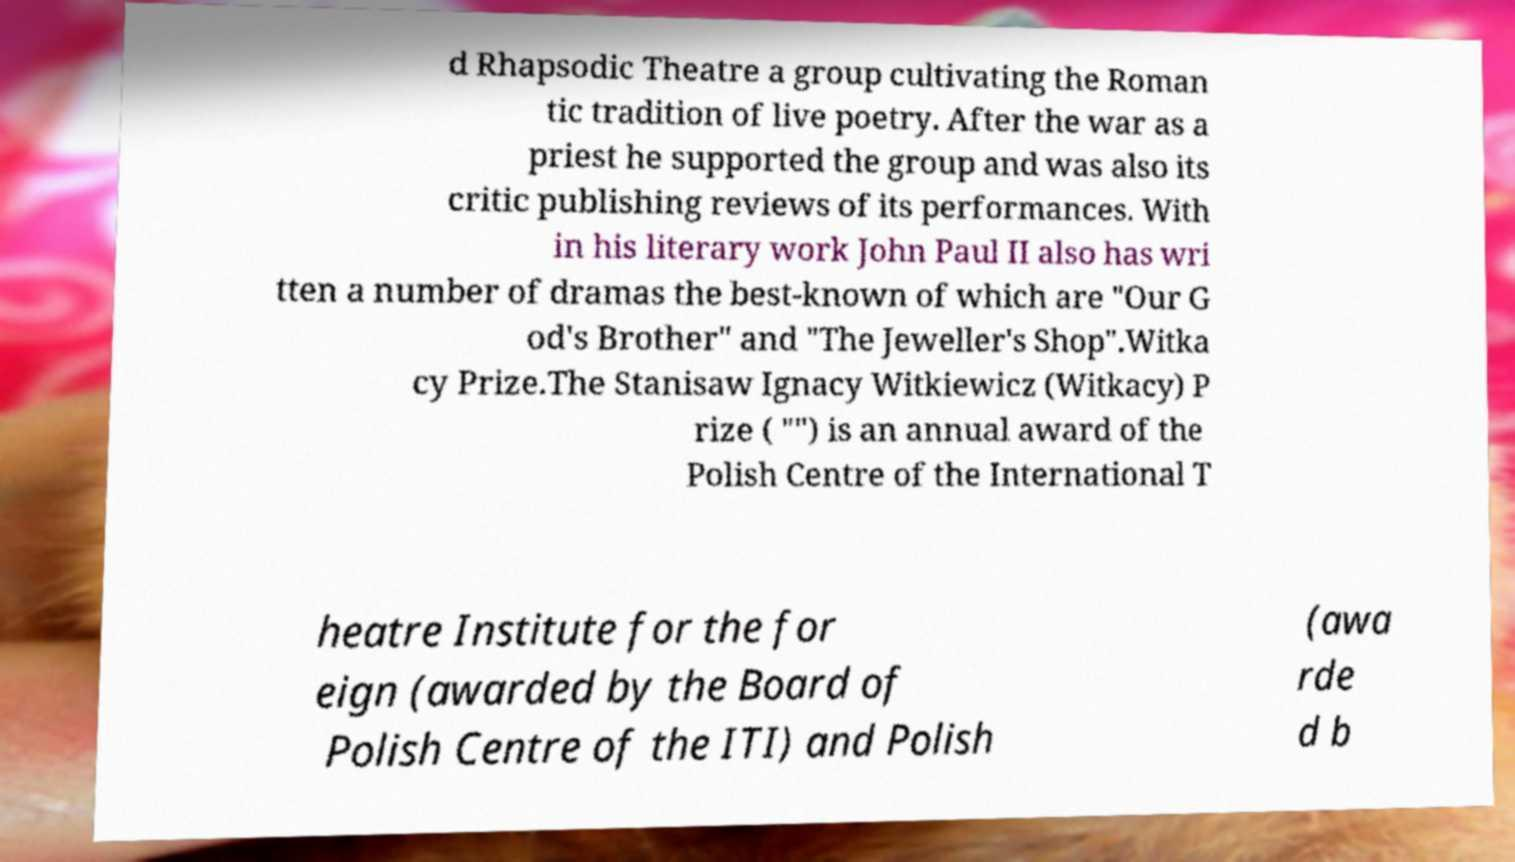Can you accurately transcribe the text from the provided image for me? d Rhapsodic Theatre a group cultivating the Roman tic tradition of live poetry. After the war as a priest he supported the group and was also its critic publishing reviews of its performances. With in his literary work John Paul II also has wri tten a number of dramas the best-known of which are "Our G od's Brother" and "The Jeweller's Shop".Witka cy Prize.The Stanisaw Ignacy Witkiewicz (Witkacy) P rize ( "") is an annual award of the Polish Centre of the International T heatre Institute for the for eign (awarded by the Board of Polish Centre of the ITI) and Polish (awa rde d b 